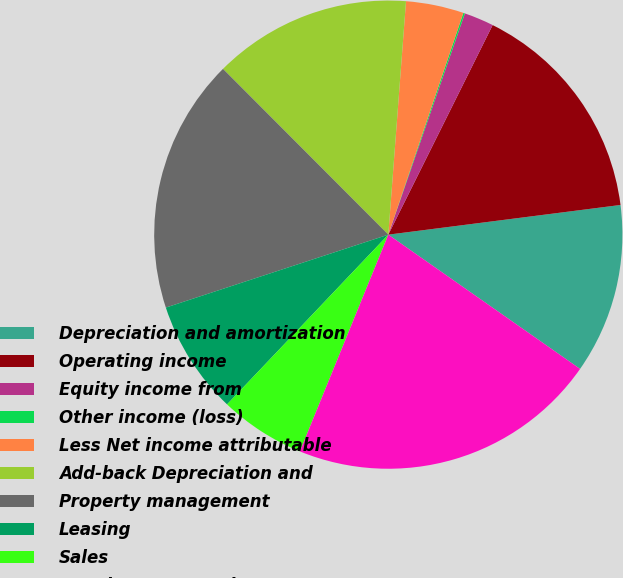<chart> <loc_0><loc_0><loc_500><loc_500><pie_chart><fcel>Depreciation and amortization<fcel>Operating income<fcel>Equity income from<fcel>Other income (loss)<fcel>Less Net income attributable<fcel>Add-back Depreciation and<fcel>Property management<fcel>Leasing<fcel>Sales<fcel>Development services<nl><fcel>11.75%<fcel>15.63%<fcel>2.05%<fcel>0.11%<fcel>3.99%<fcel>13.69%<fcel>17.57%<fcel>7.87%<fcel>5.93%<fcel>21.45%<nl></chart> 